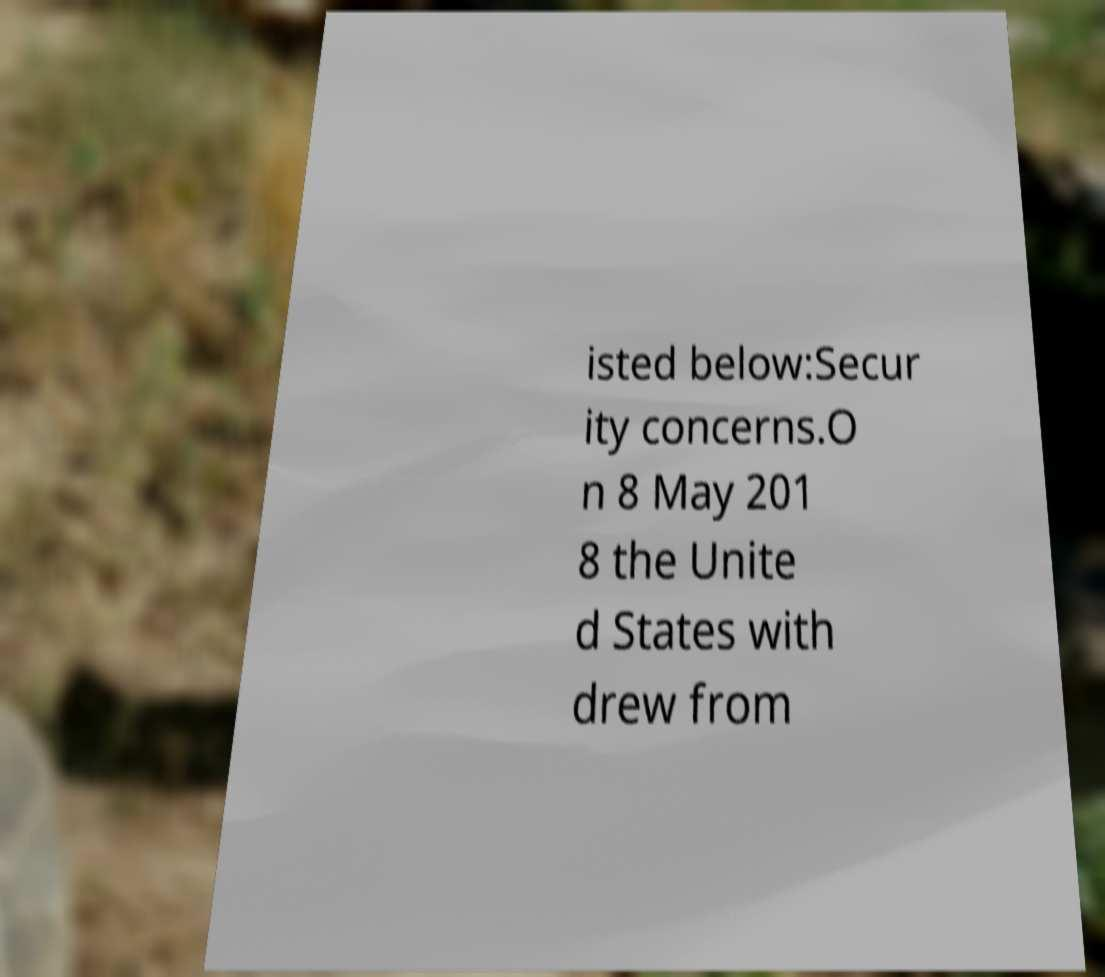Please read and relay the text visible in this image. What does it say? isted below:Secur ity concerns.O n 8 May 201 8 the Unite d States with drew from 